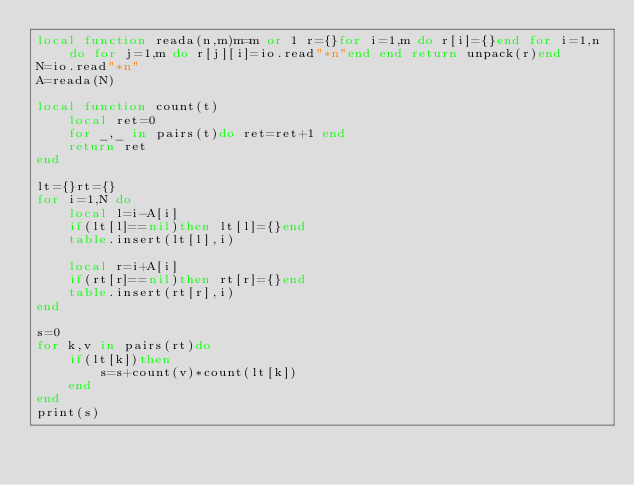<code> <loc_0><loc_0><loc_500><loc_500><_Lua_>local function reada(n,m)m=m or 1 r={}for i=1,m do r[i]={}end for i=1,n do for j=1,m do r[j][i]=io.read"*n"end end return unpack(r)end
N=io.read"*n"
A=reada(N)

local function count(t)
	local ret=0
	for _,_ in pairs(t)do ret=ret+1 end
	return ret
end

lt={}rt={}
for i=1,N do
	local l=i-A[i]
	if(lt[l]==nil)then lt[l]={}end
	table.insert(lt[l],i)
	
	local r=i+A[i]
	if(rt[r]==nil)then rt[r]={}end
	table.insert(rt[r],i)
end

s=0
for k,v in pairs(rt)do
	if(lt[k])then
		s=s+count(v)*count(lt[k])
	end
end
print(s)
</code> 